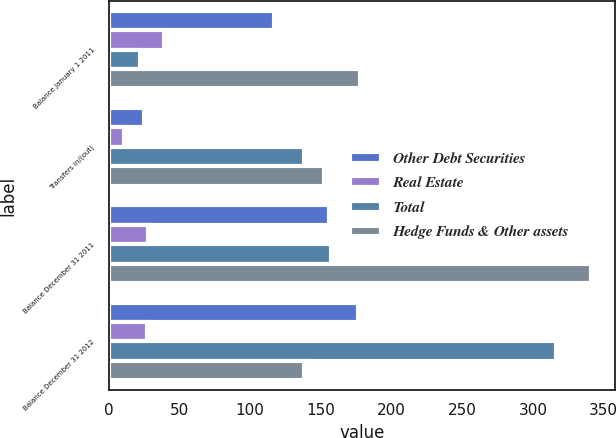<chart> <loc_0><loc_0><loc_500><loc_500><stacked_bar_chart><ecel><fcel>Balance January 1 2011<fcel>Transfers in/(out)<fcel>Balance December 31 2011<fcel>Balance December 31 2012<nl><fcel>Other Debt Securities<fcel>117<fcel>25<fcel>156<fcel>176<nl><fcel>Real Estate<fcel>39<fcel>11<fcel>28<fcel>27<nl><fcel>Total<fcel>22<fcel>138<fcel>157<fcel>316<nl><fcel>Hedge Funds & Other assets<fcel>178<fcel>152<fcel>341<fcel>138<nl></chart> 